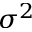Convert formula to latex. <formula><loc_0><loc_0><loc_500><loc_500>\sigma ^ { 2 }</formula> 